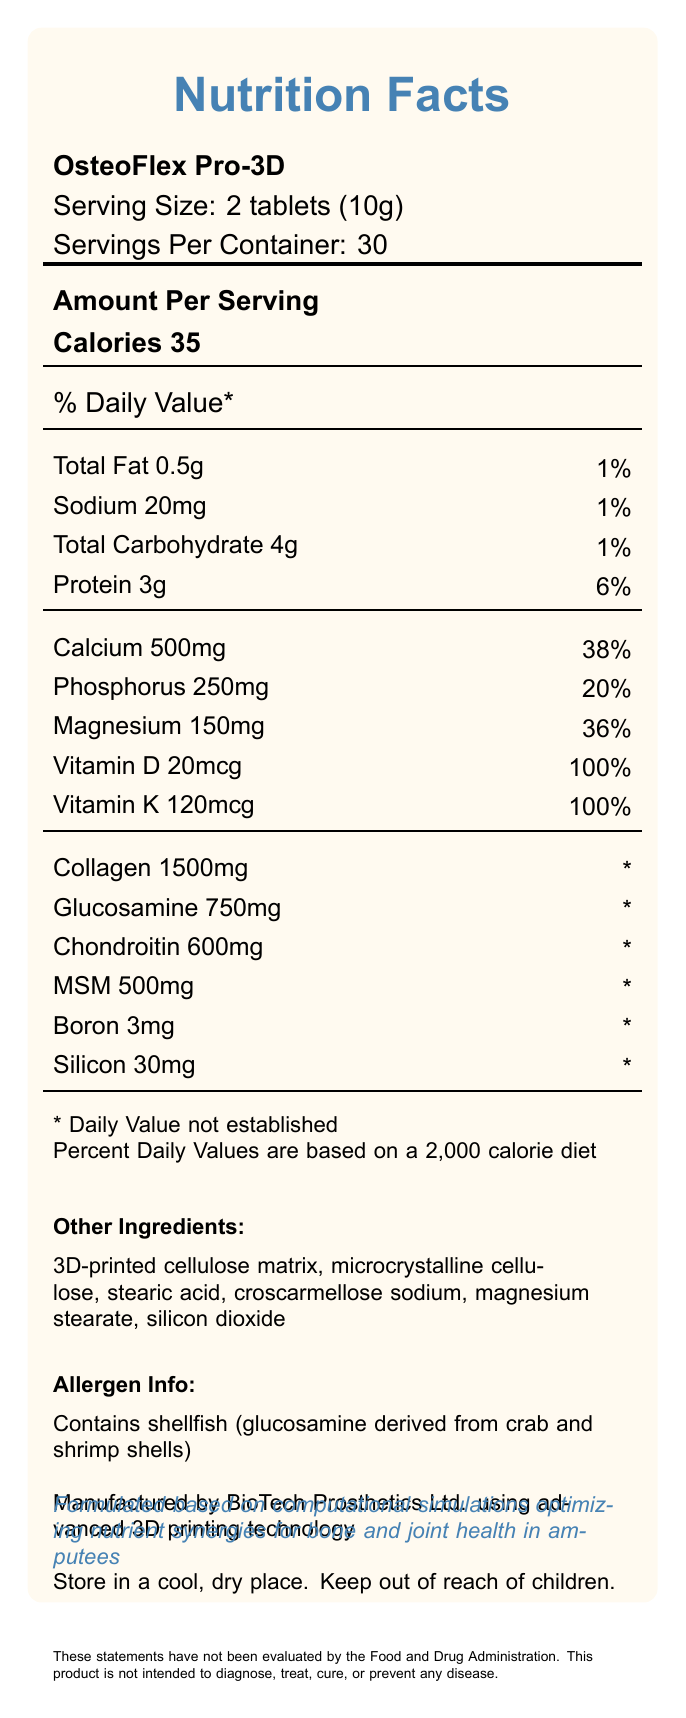How many servings are there in one container of OsteoFlex Pro-3D? The document states that there are 30 servings per container.
Answer: 30 What is the serving size for OsteoFlex Pro-3D? The document states the serving size is 2 tablets, which amounts to 10 grams.
Answer: 2 tablets (10g) How many calories are in each serving of OsteoFlex Pro-3D? The document states that each serving contains 35 calories.
Answer: 35 What is the amount of protein per serving of OsteoFlex Pro-3D? The document states that each serving contains 3 grams of protein.
Answer: 3g What percentage of the Daily Value is provided by the calcium content per serving? According to the document, the calcium content per serving provides 38% of the Daily Value.
Answer: 38% Which nutrient contributes 100% of the Daily Value per serving?  
A. Magnesium  
B. Vitamin K  
C. Protein  
D. Sodium The document states that Vitamin K provides 100% of the Daily Value per serving.
Answer: B What is the daily value percentage of magnesium per serving?  
A. 36%  
B. 20%  
C. 1%  
D. 100% The document indicates that magnesium provides 36% of the Daily Value per serving.
Answer: A Does OsteoFlex Pro-3D contain any shellfish? Under "Allergen Info," the document states that the product contains shellfish, as glucosamine is derived from crab and shrimp shells.
Answer: Yes List two ingredients in the OsteoFlex Pro-3D other than active nutrients. The "Other Ingredients" section includes non-active ingredients such as 3D-printed cellulose matrix and microcrystalline cellulose.
Answer: 3D-printed cellulose matrix, microcrystalline cellulose What is the main purpose of OsteoFlex Pro-3D as stated in the document? The main purpose is to enhance bone strength and joint health, specifically in amputees.
Answer: Optimizing nutrient synergies for bone and joint health in amputees How should OsteoFlex Pro-3D be stored? The document specifies that the product should be stored in a cool, dry place and kept out of reach of children.
Answer: In a cool, dry place, out of reach of children What is the amount of collagen per serving in OsteoFlex Pro-3D? The document lists 1500mg of collagen per serving.
Answer: 1500mg What disclaimer is provided about the product's evaluation? The disclaimer specifies that the statements have not been evaluated by the FDA and that the product is not meant to diagnose, treat, cure, or prevent any disease.
Answer: These statements have not been evaluated by the Food and Drug Administration. This product is not intended to diagnose, treat, cure, or prevent any disease. How much vitamin D is present per serving? The document states that there is 20 micrograms of vitamin D per serving.
Answer: 20mcg Is there any information about the manufacturing practices used for OsteoFlex Pro-3D? The document indicates that OsteoFlex Pro-3D is manufactured by BioTech Prosthetics Ltd. using advanced 3D printing technology.
Answer: Yes Which company manufactures OsteoFlex Pro-3D? The document states that BioTech Prosthetics Ltd. manufactures OsteoFlex Pro-3D.
Answer: BioTech Prosthetics Ltd. Summarize the primary nutritional information and purpose of OsteoFlex Pro-3D. The summary includes serving size, daily values, key nutrients, and the product's purpose and manufacturing details.
Answer: OsteoFlex Pro-3D is a 3D-printed food supplement optimized for bone strength and joint health in amputees. Each serving size is 2 tablets (10g), with 30 servings per container. It contains various nutrients, including 35 calories, 0.5g total fat, 20mg sodium, 4g carbohydrates, and 3g protein. Key nutrients include calcium (500mg, 38% DV), phosphorus (250mg, 20% DV), magnesium (150mg, 36% DV), vitamin D (20mcg, 100% DV), and vitamin K (120mcg, 100% DV). The product also includes collagen, glucosamine, chondroitin, MSM, boron, and silicon. It is manufactured by BioTech Prosthetics Ltd. using 3D printing technology, and it's formulated based on computational simulations for bone and joint health in amputees. What is the total carbohydrate content per serving? The document indicates that each serving contains 4 grams of carbohydrates.
Answer: 4g Can you determine the source of collagen in OsteoFlex Pro-3D? The document does not provide information about the source of collagen.
Answer: Cannot be determined 